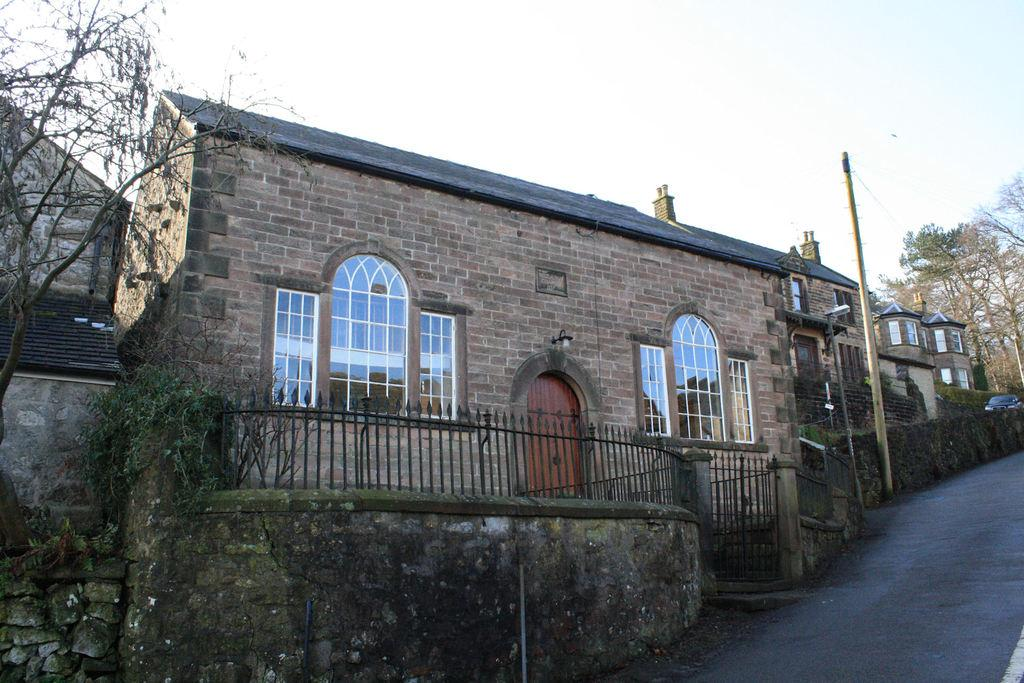What is the main structure in the center of the image? There is a house in the center of the image. What else can be seen in the image besides the house? There is a road, trees, an electric pole, and a fencing with a wall in the image. Can you tell me how many times the pump is used in the image? There is no pump present in the image, so it cannot be used any number of times. 